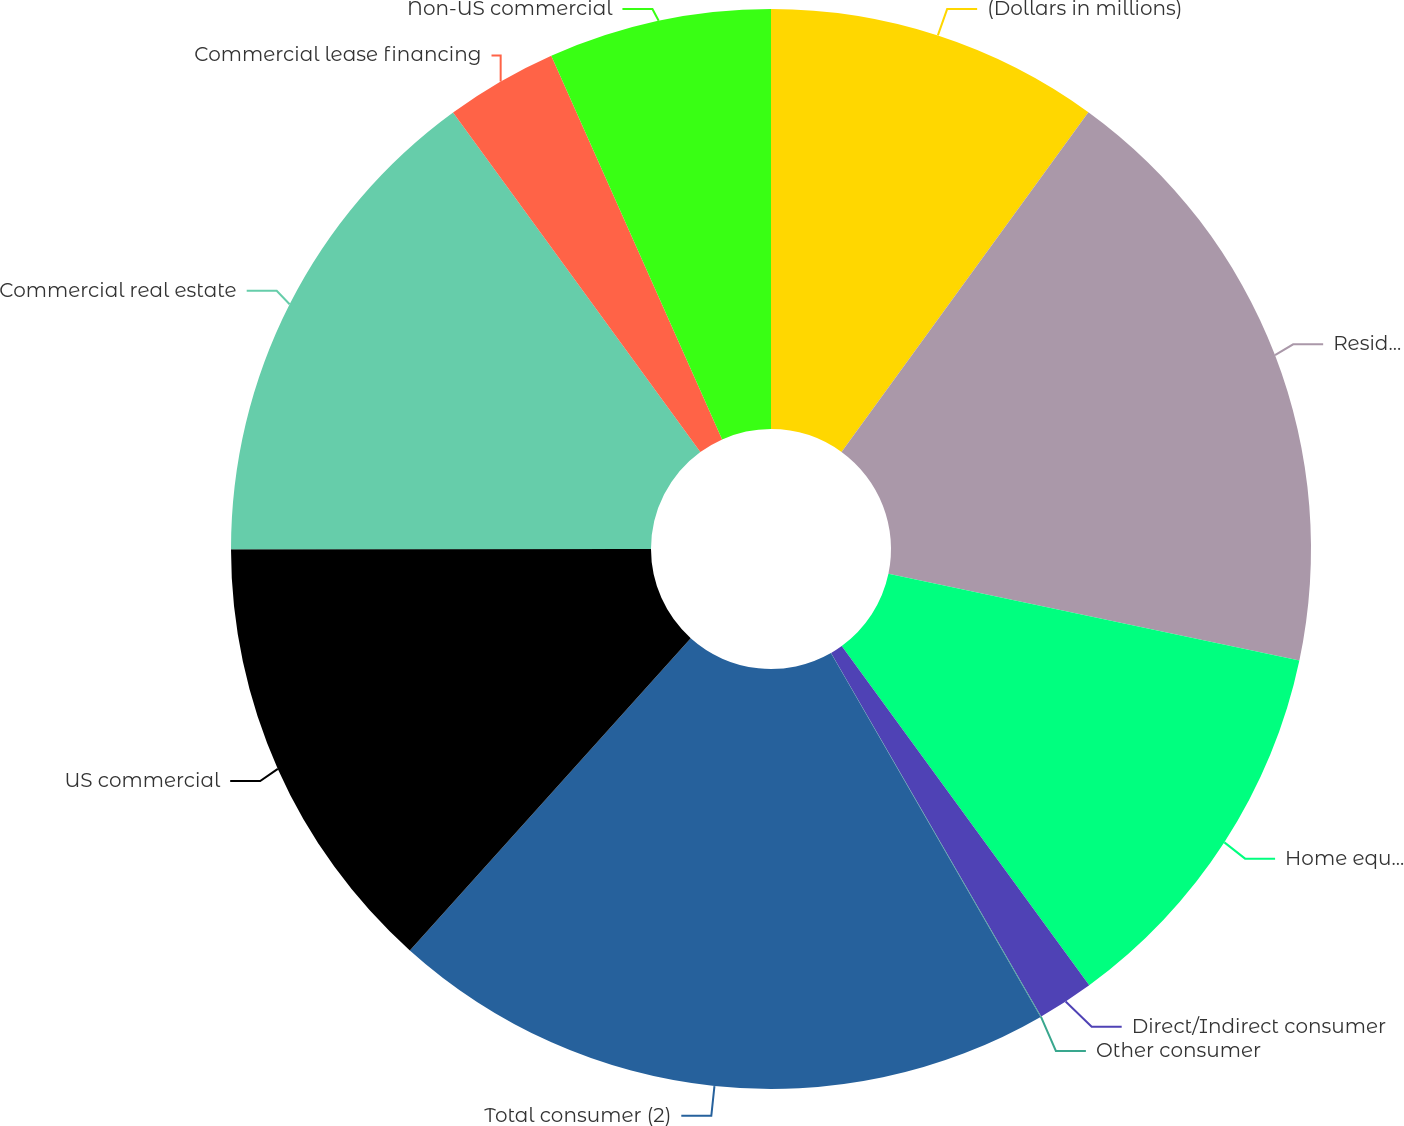Convert chart. <chart><loc_0><loc_0><loc_500><loc_500><pie_chart><fcel>(Dollars in millions)<fcel>Residential mortgage<fcel>Home equity<fcel>Direct/Indirect consumer<fcel>Other consumer<fcel>Total consumer (2)<fcel>US commercial<fcel>Commercial real estate<fcel>Commercial lease financing<fcel>Non-US commercial<nl><fcel>10.0%<fcel>18.31%<fcel>11.66%<fcel>1.69%<fcel>0.02%<fcel>19.98%<fcel>13.33%<fcel>14.99%<fcel>3.35%<fcel>6.67%<nl></chart> 